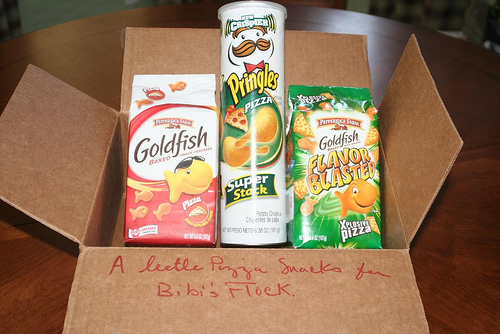<image>
Can you confirm if the fish is next to the fish blasts? No. The fish is not positioned next to the fish blasts. They are located in different areas of the scene. 